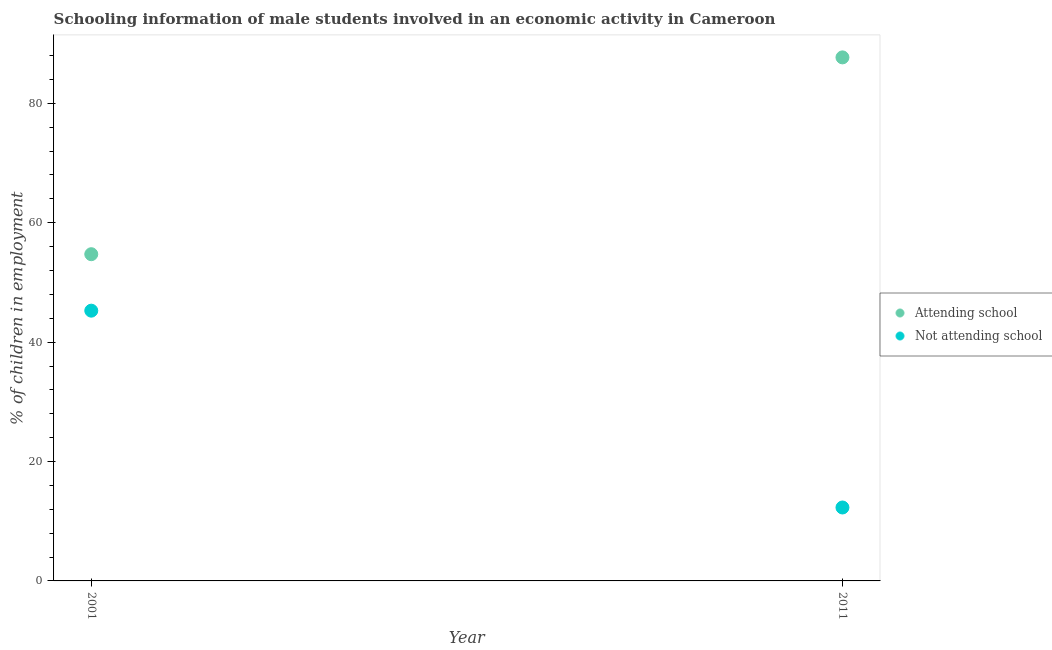Across all years, what is the maximum percentage of employed males who are not attending school?
Provide a short and direct response. 45.27. Across all years, what is the minimum percentage of employed males who are attending school?
Your response must be concise. 54.73. In which year was the percentage of employed males who are not attending school minimum?
Keep it short and to the point. 2011. What is the total percentage of employed males who are not attending school in the graph?
Make the answer very short. 57.57. What is the difference between the percentage of employed males who are not attending school in 2001 and that in 2011?
Provide a short and direct response. 32.97. What is the difference between the percentage of employed males who are not attending school in 2011 and the percentage of employed males who are attending school in 2001?
Offer a very short reply. -42.43. What is the average percentage of employed males who are attending school per year?
Give a very brief answer. 71.21. In the year 2001, what is the difference between the percentage of employed males who are attending school and percentage of employed males who are not attending school?
Provide a short and direct response. 9.46. What is the ratio of the percentage of employed males who are not attending school in 2001 to that in 2011?
Keep it short and to the point. 3.68. Is the percentage of employed males who are not attending school strictly greater than the percentage of employed males who are attending school over the years?
Your response must be concise. No. How many years are there in the graph?
Your response must be concise. 2. What is the difference between two consecutive major ticks on the Y-axis?
Make the answer very short. 20. Are the values on the major ticks of Y-axis written in scientific E-notation?
Give a very brief answer. No. Does the graph contain any zero values?
Provide a short and direct response. No. Where does the legend appear in the graph?
Keep it short and to the point. Center right. What is the title of the graph?
Provide a short and direct response. Schooling information of male students involved in an economic activity in Cameroon. Does "Travel Items" appear as one of the legend labels in the graph?
Make the answer very short. No. What is the label or title of the Y-axis?
Offer a very short reply. % of children in employment. What is the % of children in employment in Attending school in 2001?
Ensure brevity in your answer.  54.73. What is the % of children in employment of Not attending school in 2001?
Give a very brief answer. 45.27. What is the % of children in employment of Attending school in 2011?
Provide a short and direct response. 87.7. Across all years, what is the maximum % of children in employment of Attending school?
Your response must be concise. 87.7. Across all years, what is the maximum % of children in employment of Not attending school?
Your response must be concise. 45.27. Across all years, what is the minimum % of children in employment of Attending school?
Your answer should be very brief. 54.73. Across all years, what is the minimum % of children in employment of Not attending school?
Ensure brevity in your answer.  12.3. What is the total % of children in employment of Attending school in the graph?
Make the answer very short. 142.43. What is the total % of children in employment of Not attending school in the graph?
Make the answer very short. 57.57. What is the difference between the % of children in employment in Attending school in 2001 and that in 2011?
Provide a succinct answer. -32.97. What is the difference between the % of children in employment of Not attending school in 2001 and that in 2011?
Provide a short and direct response. 32.97. What is the difference between the % of children in employment of Attending school in 2001 and the % of children in employment of Not attending school in 2011?
Give a very brief answer. 42.43. What is the average % of children in employment in Attending school per year?
Provide a succinct answer. 71.21. What is the average % of children in employment of Not attending school per year?
Give a very brief answer. 28.79. In the year 2001, what is the difference between the % of children in employment in Attending school and % of children in employment in Not attending school?
Your answer should be very brief. 9.46. In the year 2011, what is the difference between the % of children in employment in Attending school and % of children in employment in Not attending school?
Your answer should be compact. 75.4. What is the ratio of the % of children in employment of Attending school in 2001 to that in 2011?
Your response must be concise. 0.62. What is the ratio of the % of children in employment of Not attending school in 2001 to that in 2011?
Provide a short and direct response. 3.68. What is the difference between the highest and the second highest % of children in employment of Attending school?
Ensure brevity in your answer.  32.97. What is the difference between the highest and the second highest % of children in employment in Not attending school?
Give a very brief answer. 32.97. What is the difference between the highest and the lowest % of children in employment in Attending school?
Give a very brief answer. 32.97. What is the difference between the highest and the lowest % of children in employment in Not attending school?
Keep it short and to the point. 32.97. 